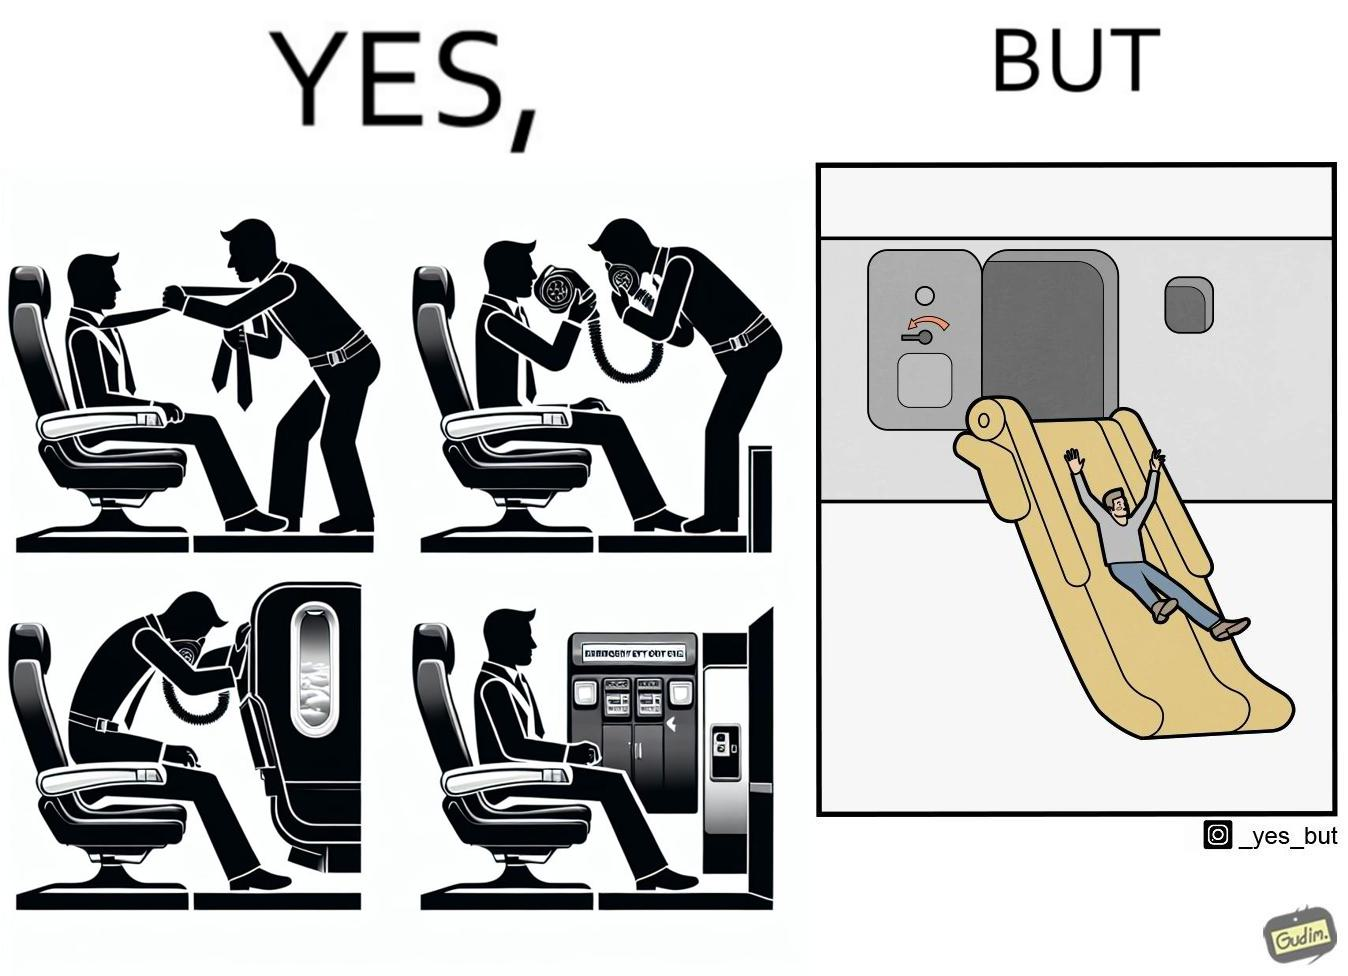Would you classify this image as satirical? Yes, this image is satirical. 